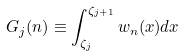<formula> <loc_0><loc_0><loc_500><loc_500>G _ { j } ( n ) \equiv \int _ { \zeta _ { j } } ^ { \zeta _ { j + 1 } } w _ { n } ( x ) d x</formula> 